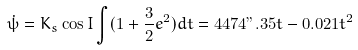Convert formula to latex. <formula><loc_0><loc_0><loc_500><loc_500>\dot { \psi } = K _ { s } \cos I \int ( 1 + \frac { 3 } { 2 } e ^ { 2 } ) d t = 4 4 7 4 " . 3 5 t - 0 . 0 2 1 t ^ { 2 }</formula> 